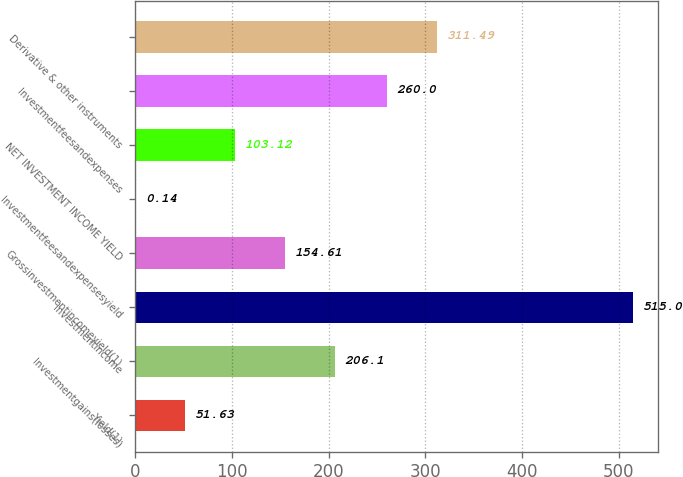<chart> <loc_0><loc_0><loc_500><loc_500><bar_chart><fcel>Yield(1)<fcel>Investmentgains(losses)<fcel>Investmentincome<fcel>Grossinvestmentincomeyield(1)<fcel>Investmentfeesandexpensesyield<fcel>NET INVESTMENT INCOME YIELD<fcel>Investmentfeesandexpenses<fcel>Derivative & other instruments<nl><fcel>51.63<fcel>206.1<fcel>515<fcel>154.61<fcel>0.14<fcel>103.12<fcel>260<fcel>311.49<nl></chart> 